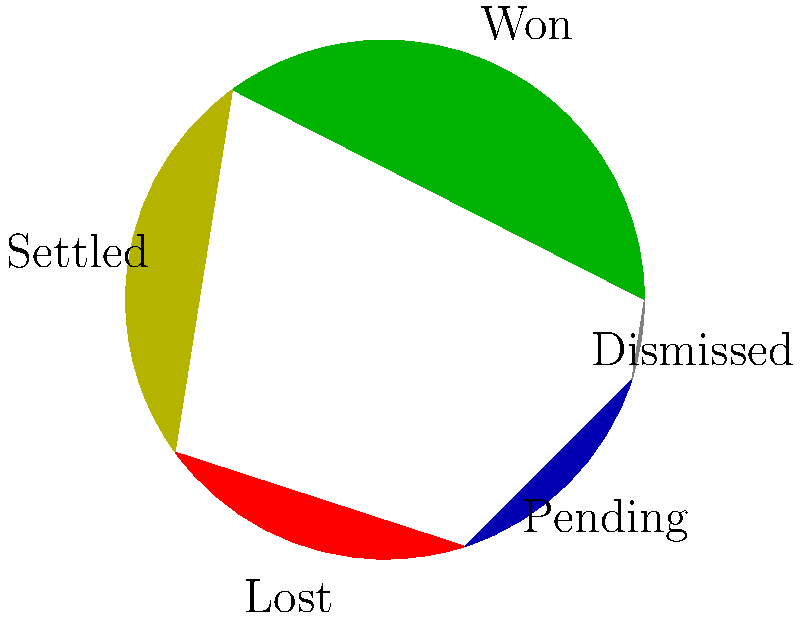As a defense attorney representing employers, you are analyzing your firm's historical performance in labor dispute cases. The pie chart shows the outcomes of 200 cases handled by your firm. Given this data, what is the probability of winning a case if it goes to trial (i.e., not settled or dismissed)? To calculate the probability of winning a case that goes to trial, we need to follow these steps:

1. Identify the total number of cases: 200

2. Determine the number of cases that went to trial:
   - Won cases: 35% of 200 = 70 cases
   - Lost cases: 20% of 200 = 40 cases
   - Total cases that went to trial = 70 + 40 = 110 cases

3. Calculate the number of won cases among those that went to trial:
   - Won cases: 70

4. Calculate the probability of winning a case that goes to trial:
   $P(\text{Winning} | \text{Trial}) = \frac{\text{Number of won cases}}{\text{Total cases that went to trial}}$
   
   $P(\text{Winning} | \text{Trial}) = \frac{70}{110} = \frac{7}{11} \approx 0.6364$

Therefore, the probability of winning a case that goes to trial is $\frac{7}{11}$ or approximately 63.64%.
Answer: $\frac{7}{11}$ or 0.6364 